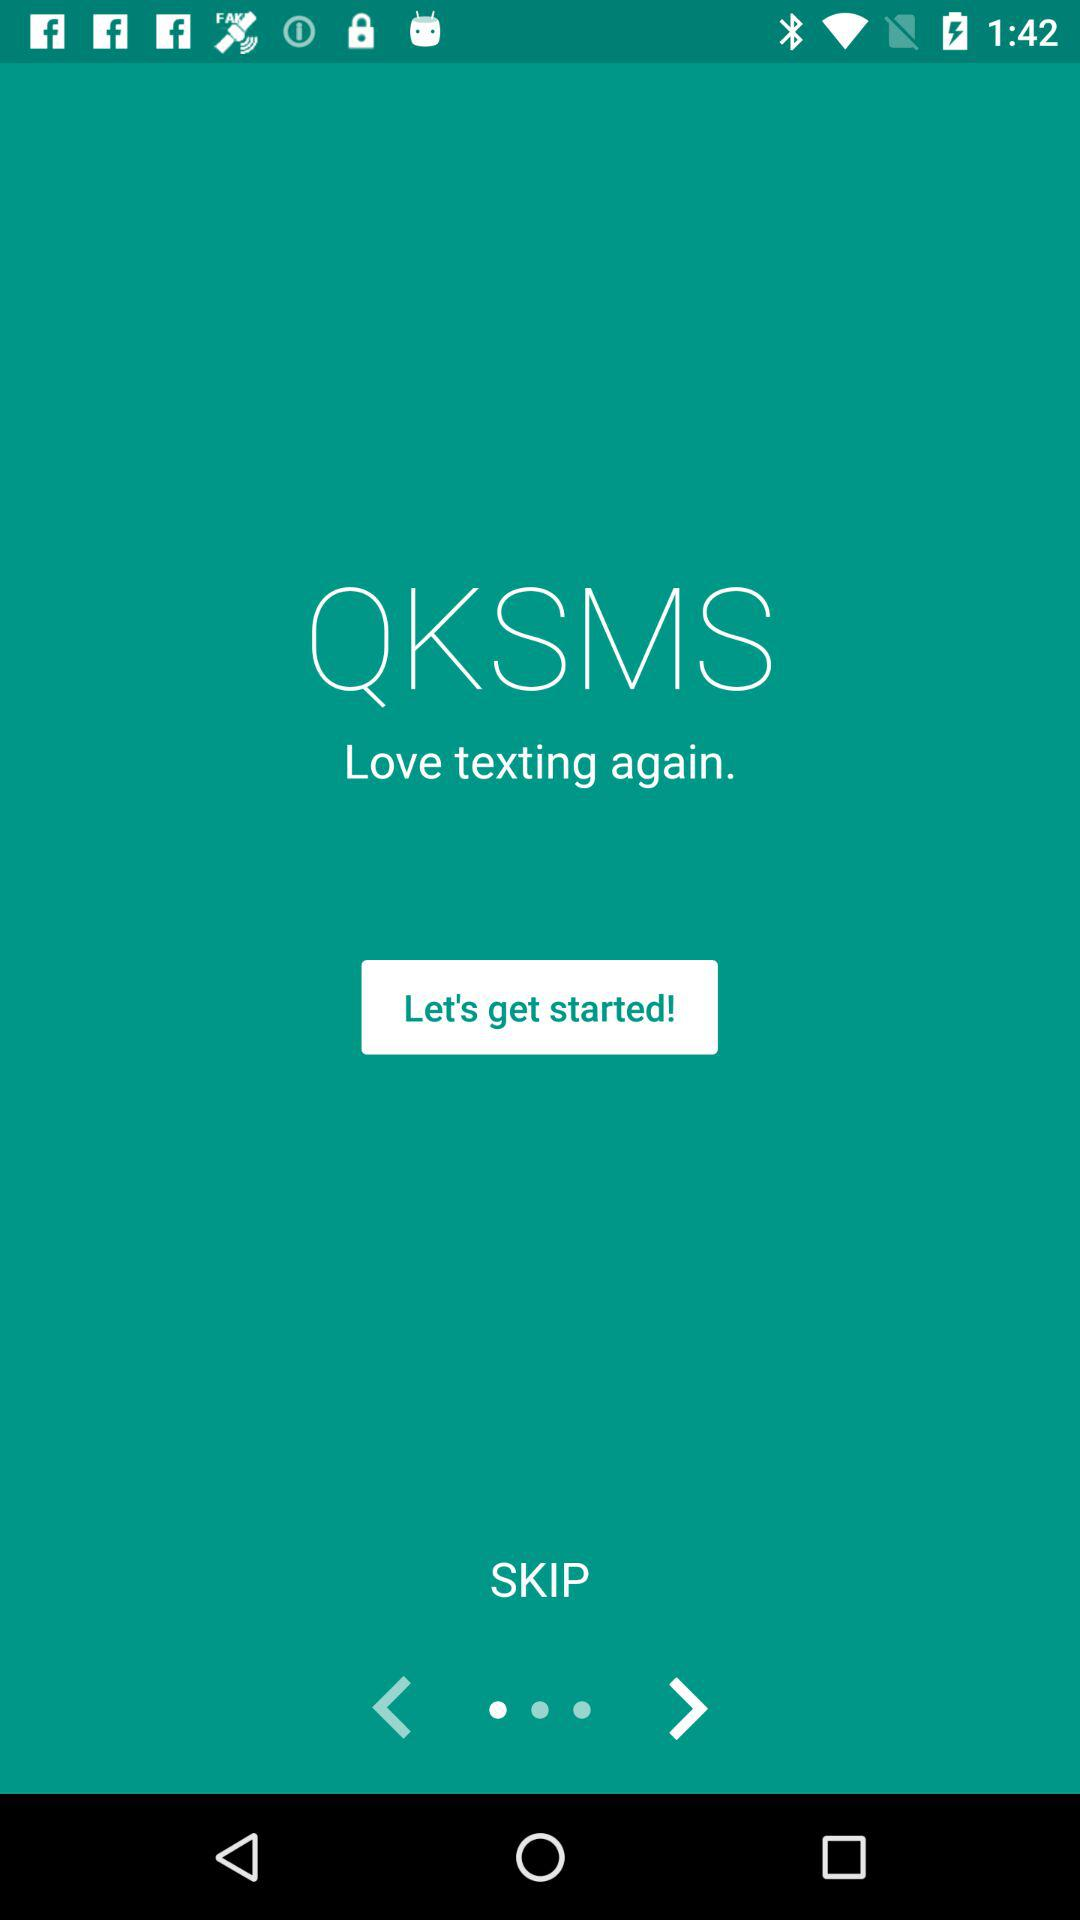What is the name of the application? The name of the application is "QKSMS". 